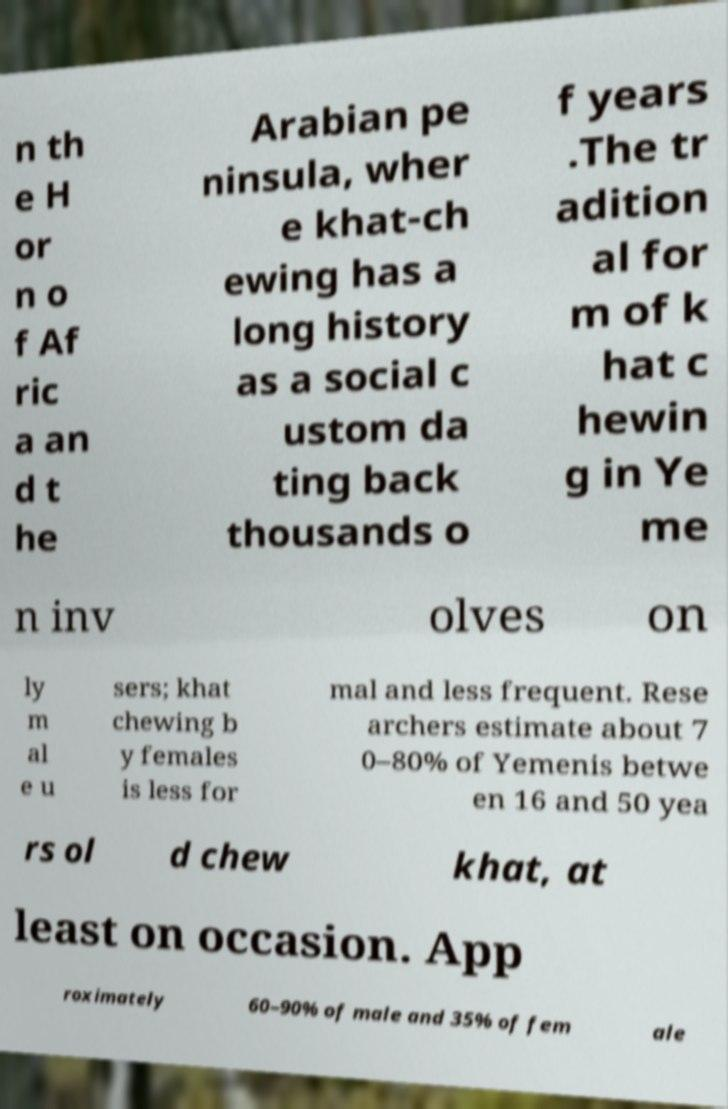I need the written content from this picture converted into text. Can you do that? n th e H or n o f Af ric a an d t he Arabian pe ninsula, wher e khat-ch ewing has a long history as a social c ustom da ting back thousands o f years .The tr adition al for m of k hat c hewin g in Ye me n inv olves on ly m al e u sers; khat chewing b y females is less for mal and less frequent. Rese archers estimate about 7 0–80% of Yemenis betwe en 16 and 50 yea rs ol d chew khat, at least on occasion. App roximately 60–90% of male and 35% of fem ale 